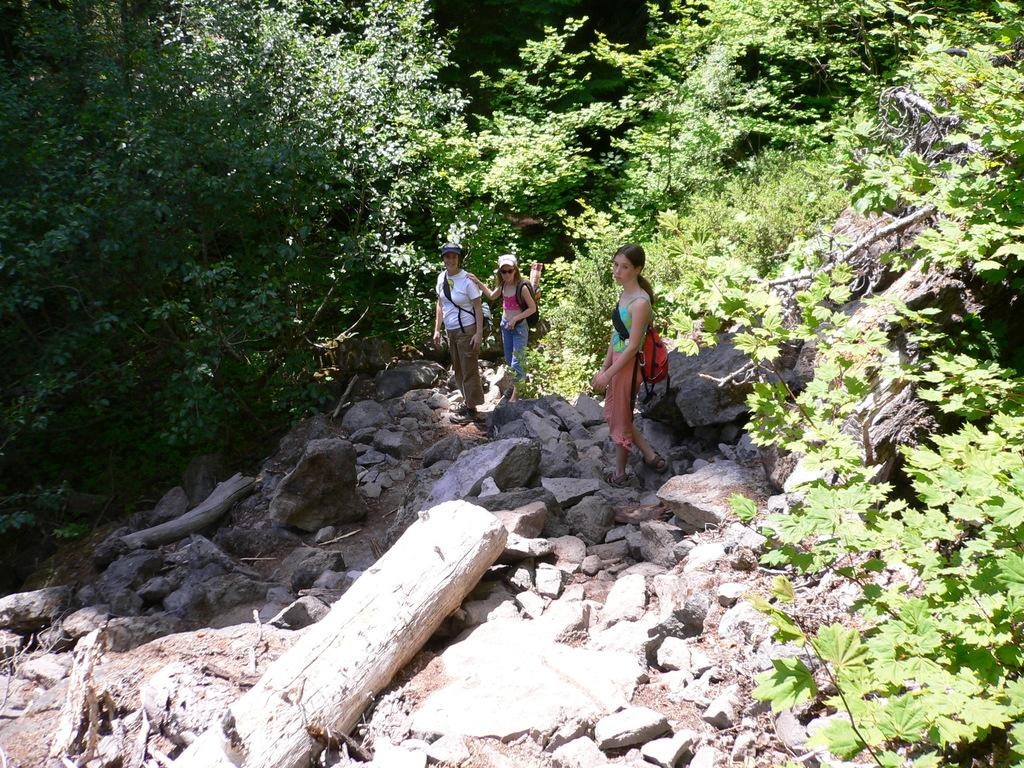How many people are present in the image? There are three people standing in the image. What objects are in front of the people? There are rocks and wooden logs in front of the people. What type of vegetation can be seen behind the people? There are trees visible behind the people. What type of hole can be seen in the image? There is no hole present in the image. How many dogs are visible in the image? There are no dogs present in the image. 